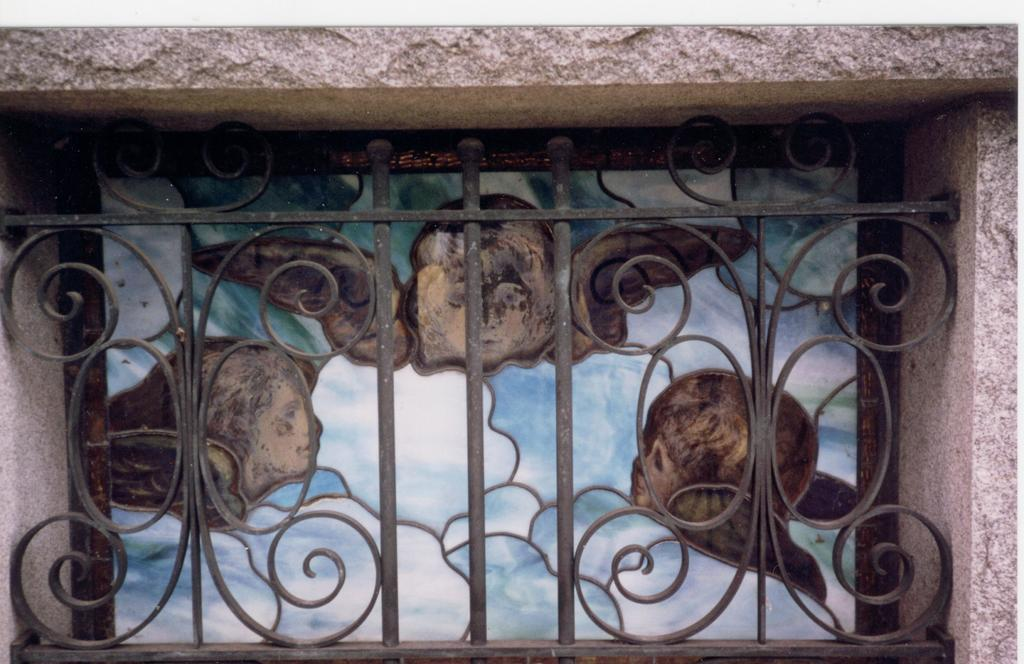What type of window is visible in the image? There is a ventilator window in the image. Can you describe any additional features near the window? There is a frame present near the window. What type of stitch is used to hold the cave together in the image? There is no cave present in the image, and therefore no stitch can be observed. 